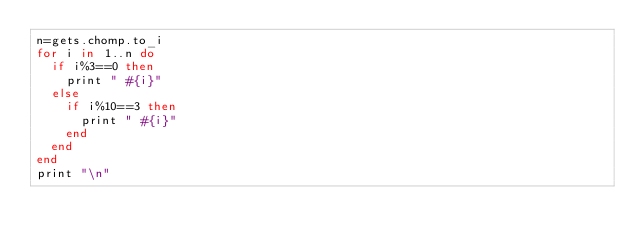<code> <loc_0><loc_0><loc_500><loc_500><_Ruby_>n=gets.chomp.to_i
for i in 1..n do
  if i%3==0 then
    print " #{i}"
  else
    if i%10==3 then
      print " #{i}"
    end
  end
end
print "\n"</code> 